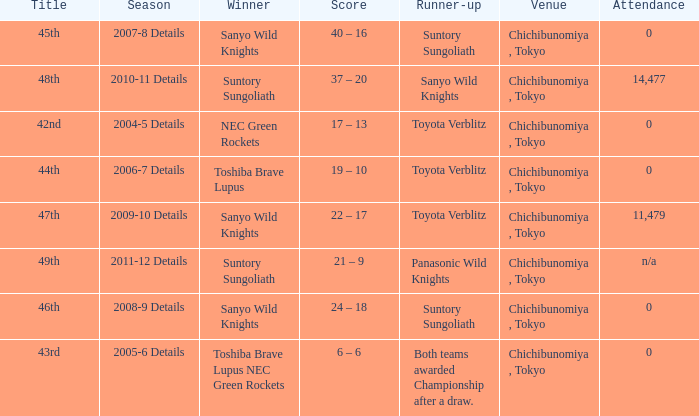What is the Title when the winner was suntory sungoliath, and a Season of 2011-12 details? 49th. 